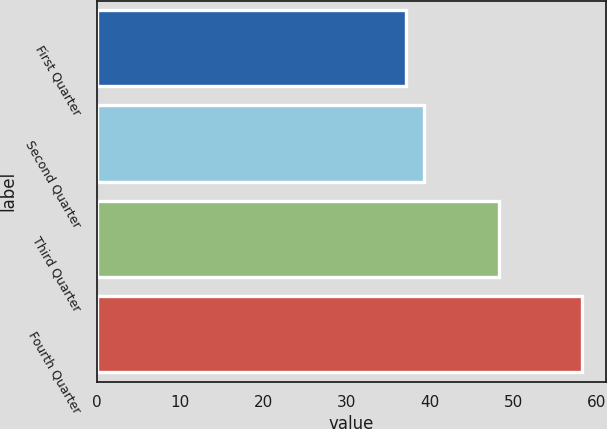<chart> <loc_0><loc_0><loc_500><loc_500><bar_chart><fcel>First Quarter<fcel>Second Quarter<fcel>Third Quarter<fcel>Fourth Quarter<nl><fcel>37.15<fcel>39.26<fcel>48.33<fcel>58.24<nl></chart> 